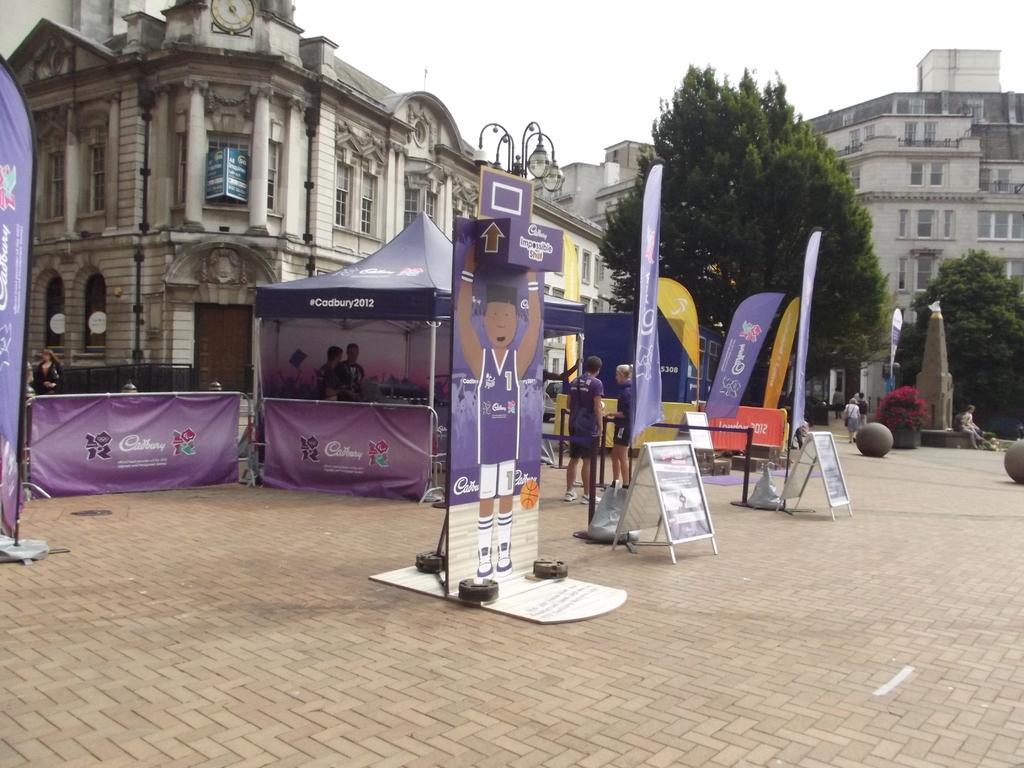How would you summarize this image in a sentence or two? In this image we can see a group of people standing on the ground. In the foreground of the image we can see some sign boards placed on the ground with some text on them. To the left side of the image we can see a person sitting on the wall. In the background, we can see a shed and some banners with some text, a group of buildings with windows, a group of trees, light poles and the sky. 